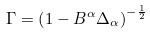Convert formula to latex. <formula><loc_0><loc_0><loc_500><loc_500>\Gamma = \left ( 1 - B ^ { \alpha } \Delta _ { \alpha } \right ) ^ { - \frac { 1 } { 2 } }</formula> 